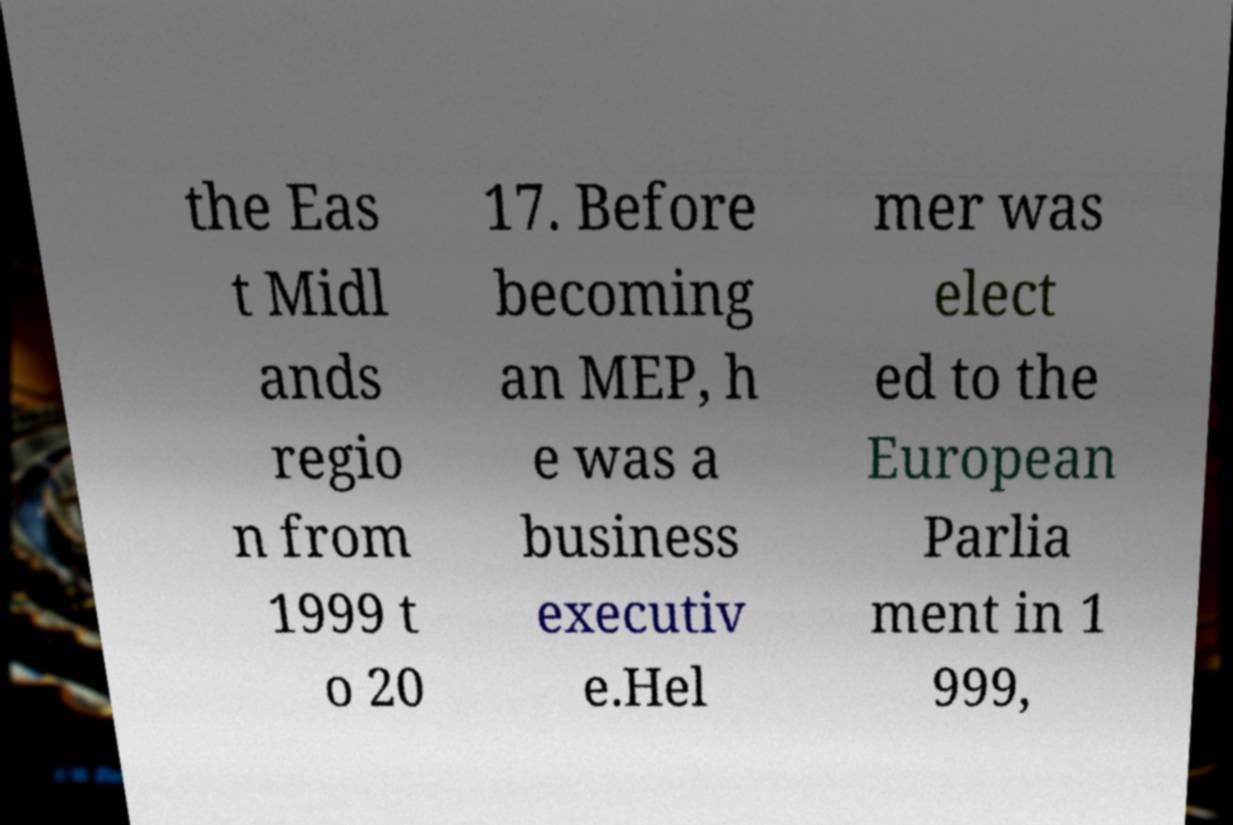Could you extract and type out the text from this image? the Eas t Midl ands regio n from 1999 t o 20 17. Before becoming an MEP, h e was a business executiv e.Hel mer was elect ed to the European Parlia ment in 1 999, 